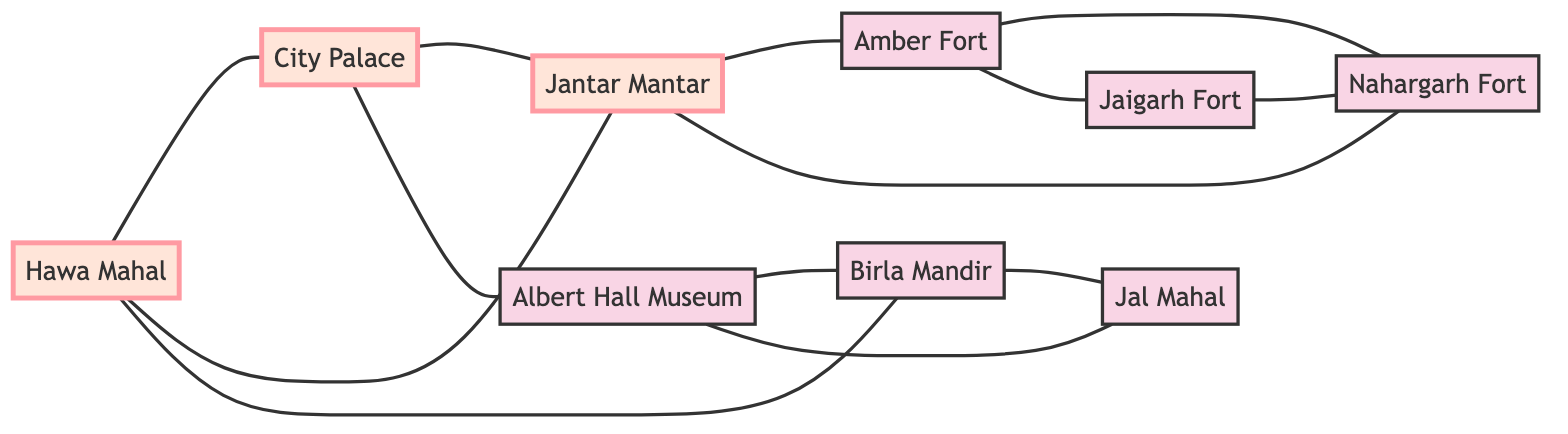What are the total number of nodes in the graph? To find the total number of nodes, count the unique locations listed in the data under "nodes". These are: Hawa Mahal, City Palace, Jantar Mantar, Amber Fort, Nahargarh Fort, Jaigarh Fort, Albert Hall Museum, Birla Mandir, and Jal Mahal. Counting these gives a total of 9 nodes.
Answer: 9 How many edges are connected to Jantar Mantar? To determine the number of edges connected to Jantar Mantar, look at all edges originating from or terminating at this node in the "edges" section. They are: from Hawa Mahal, from City Palace, to Amber Fort, and to Nahargarh Fort. Counting these gives a total of 4 edges.
Answer: 4 Which two attractions are directly connected to Jal Mahal? Identify the edges that connect to Jal Mahal in the "edges" section. The edges are from Albert Hall Museum and from Birla Mandir. This shows that Jal Mahal is directly connected to these two attractions.
Answer: Albert Hall Museum, Birla Mandir Is there a direct connection between Amber Fort and Nahargarh Fort? Check the edges for a direct connection between these two nodes. The edge data shows there is a connection: Amber Fort is connected to Nahargarh Fort. Thus, they are directly connected.
Answer: Yes How many attractions connect to Hawa Mahal? Count the edges that connect to Hawa Mahal from the "edges" section. Hawa Mahal connects to City Palace, Jantar Mantar, and Birla Mandir. There are three direct connections, so the count is 3.
Answer: 3 Which node is connected to both City Palace and Albert Hall Museum? Examine the edges to find nodes that connect to both City Palace and Albert Hall Museum. The only node found connecting to both is Hawa Mahal, which shares an edge with both these locations.
Answer: Hawa Mahal What is the relationship between Amber Fort and Jaigarh Fort? Look for the edge(s) connecting Amber Fort and Jaigarh Fort in the "edges" section. The data shows that they are connected, which indicates a direct relationship between the two.
Answer: Yes Which attraction connects the most number of edges? Analyze the connections of each node: Hawa Mahal connects to 3 edges, City Palace to 2, Jantar Mantar to 4, Amber Fort to 2, Nahargarh Fort to 3, Jaigarh Fort to 2, Albert Hall Museum to 2, Birla Mandir to 3, and Jal Mahal to 2. The highest is Jantar Mantar with 4 edges.
Answer: Jantar Mantar 